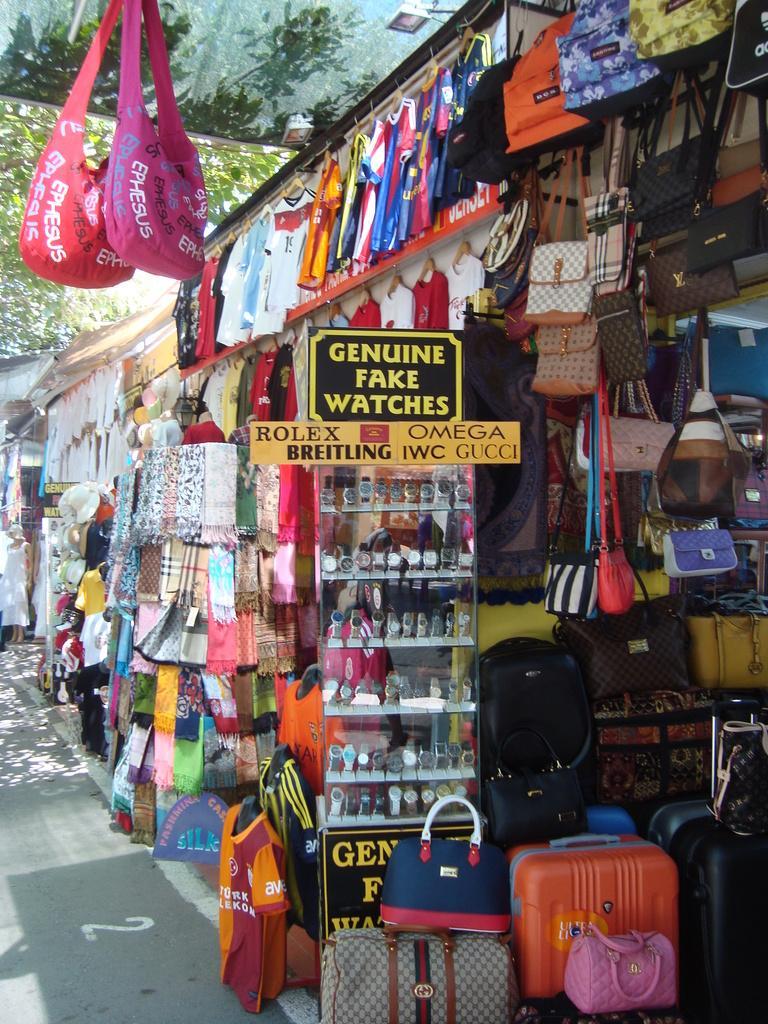Describe this image in one or two sentences. The picture is clicked on a road where there are shops of hand bags and watches and there is a label on top of that which is Genuine fake watches. 